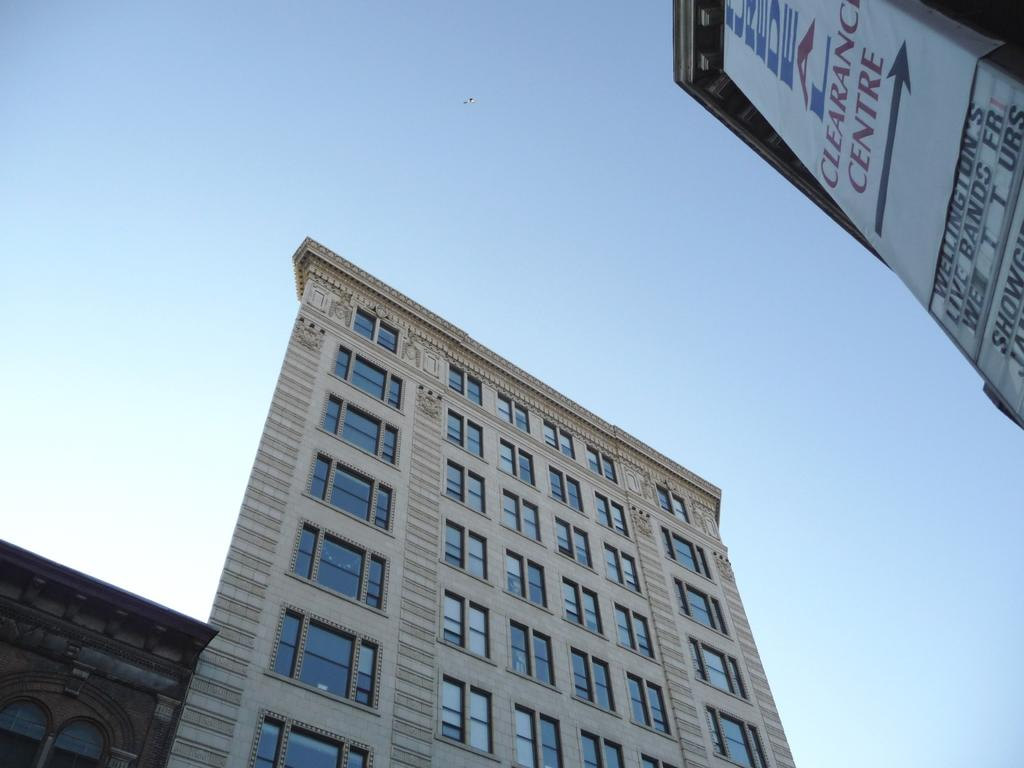What type of structures can be seen in the image? There are buildings in the image. What can be seen in the background of the image? The sky is visible in the background of the image. Where is the banner located in the image? The banner is in the top right-hand side of the image. What is written on the banner? There is text on the banner. What type of stitch is used to create the wall in the image? There is no mention of a wall or stitch in the image; it features buildings and a banner with text. 